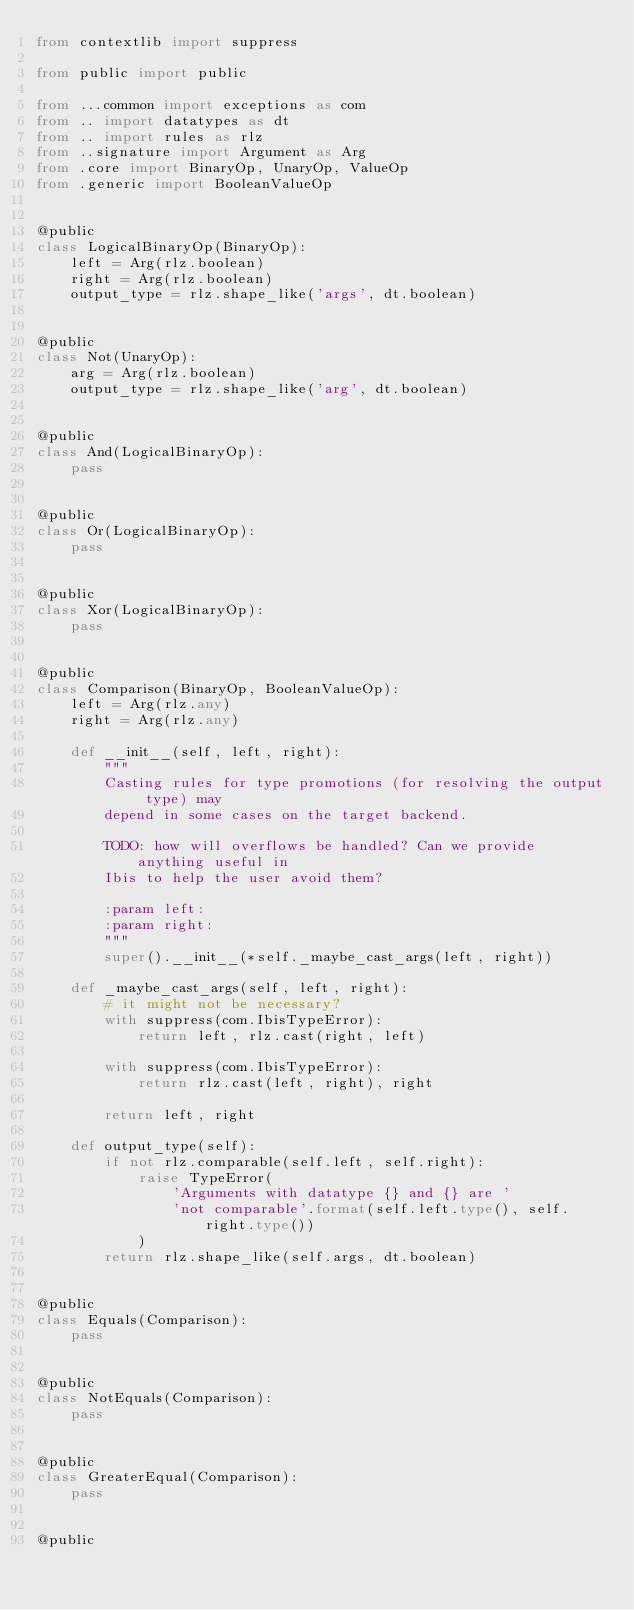Convert code to text. <code><loc_0><loc_0><loc_500><loc_500><_Python_>from contextlib import suppress

from public import public

from ...common import exceptions as com
from .. import datatypes as dt
from .. import rules as rlz
from ..signature import Argument as Arg
from .core import BinaryOp, UnaryOp, ValueOp
from .generic import BooleanValueOp


@public
class LogicalBinaryOp(BinaryOp):
    left = Arg(rlz.boolean)
    right = Arg(rlz.boolean)
    output_type = rlz.shape_like('args', dt.boolean)


@public
class Not(UnaryOp):
    arg = Arg(rlz.boolean)
    output_type = rlz.shape_like('arg', dt.boolean)


@public
class And(LogicalBinaryOp):
    pass


@public
class Or(LogicalBinaryOp):
    pass


@public
class Xor(LogicalBinaryOp):
    pass


@public
class Comparison(BinaryOp, BooleanValueOp):
    left = Arg(rlz.any)
    right = Arg(rlz.any)

    def __init__(self, left, right):
        """
        Casting rules for type promotions (for resolving the output type) may
        depend in some cases on the target backend.

        TODO: how will overflows be handled? Can we provide anything useful in
        Ibis to help the user avoid them?

        :param left:
        :param right:
        """
        super().__init__(*self._maybe_cast_args(left, right))

    def _maybe_cast_args(self, left, right):
        # it might not be necessary?
        with suppress(com.IbisTypeError):
            return left, rlz.cast(right, left)

        with suppress(com.IbisTypeError):
            return rlz.cast(left, right), right

        return left, right

    def output_type(self):
        if not rlz.comparable(self.left, self.right):
            raise TypeError(
                'Arguments with datatype {} and {} are '
                'not comparable'.format(self.left.type(), self.right.type())
            )
        return rlz.shape_like(self.args, dt.boolean)


@public
class Equals(Comparison):
    pass


@public
class NotEquals(Comparison):
    pass


@public
class GreaterEqual(Comparison):
    pass


@public</code> 